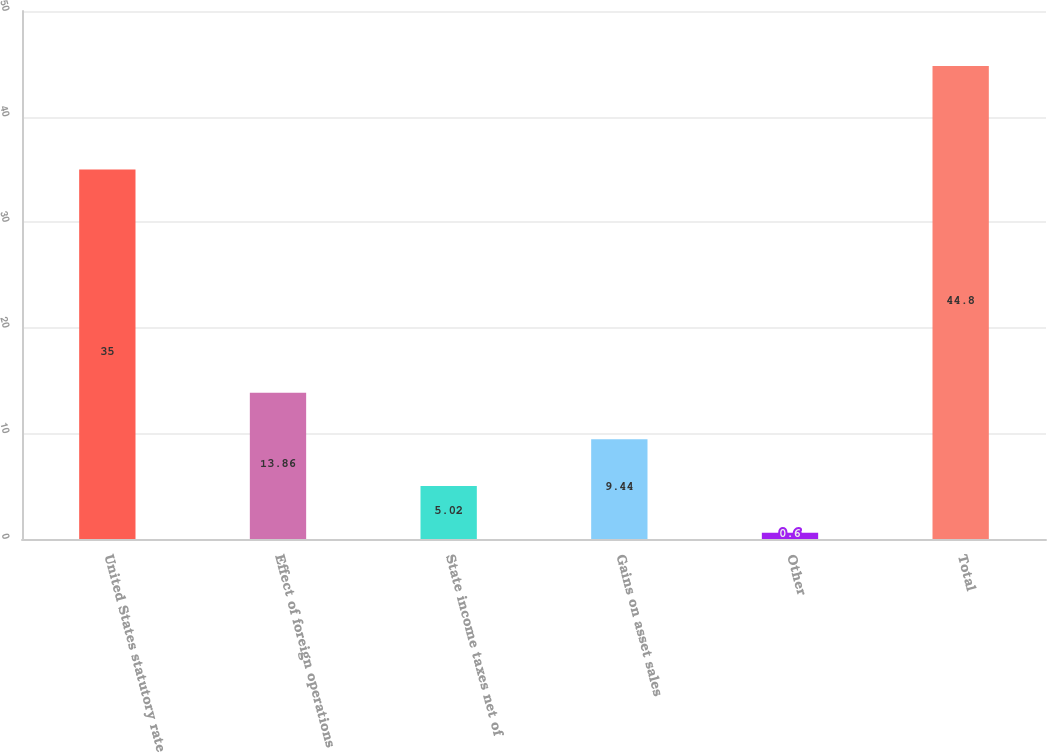Convert chart to OTSL. <chart><loc_0><loc_0><loc_500><loc_500><bar_chart><fcel>United States statutory rate<fcel>Effect of foreign operations<fcel>State income taxes net of<fcel>Gains on asset sales<fcel>Other<fcel>Total<nl><fcel>35<fcel>13.86<fcel>5.02<fcel>9.44<fcel>0.6<fcel>44.8<nl></chart> 